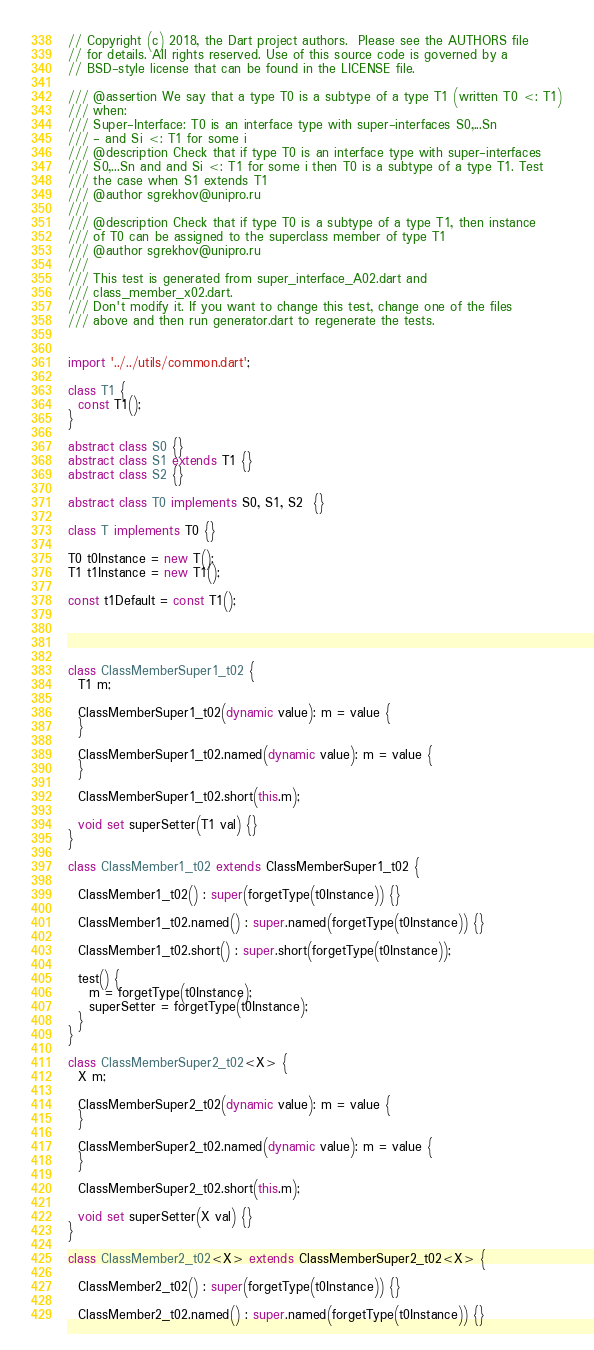Convert code to text. <code><loc_0><loc_0><loc_500><loc_500><_Dart_>// Copyright (c) 2018, the Dart project authors.  Please see the AUTHORS file
// for details. All rights reserved. Use of this source code is governed by a
// BSD-style license that can be found in the LICENSE file.

/// @assertion We say that a type T0 is a subtype of a type T1 (written T0 <: T1)
/// when:
/// Super-Interface: T0 is an interface type with super-interfaces S0,...Sn
/// - and Si <: T1 for some i
/// @description Check that if type T0 is an interface type with super-interfaces
/// S0,...Sn and and Si <: T1 for some i then T0 is a subtype of a type T1. Test
/// the case when S1 extends T1
/// @author sgrekhov@unipro.ru
///
/// @description Check that if type T0 is a subtype of a type T1, then instance
/// of T0 can be assigned to the superclass member of type T1
/// @author sgrekhov@unipro.ru
///
/// This test is generated from super_interface_A02.dart and 
/// class_member_x02.dart.
/// Don't modify it. If you want to change this test, change one of the files 
/// above and then run generator.dart to regenerate the tests.


import '../../utils/common.dart';

class T1 {
  const T1();
}

abstract class S0 {}
abstract class S1 extends T1 {}
abstract class S2 {}

abstract class T0 implements S0, S1, S2  {}

class T implements T0 {}

T0 t0Instance = new T();
T1 t1Instance = new T1();

const t1Default = const T1();




class ClassMemberSuper1_t02 {
  T1 m;

  ClassMemberSuper1_t02(dynamic value): m = value {
  }

  ClassMemberSuper1_t02.named(dynamic value): m = value {
  }

  ClassMemberSuper1_t02.short(this.m);

  void set superSetter(T1 val) {}
}

class ClassMember1_t02 extends ClassMemberSuper1_t02 {

  ClassMember1_t02() : super(forgetType(t0Instance)) {}

  ClassMember1_t02.named() : super.named(forgetType(t0Instance)) {}

  ClassMember1_t02.short() : super.short(forgetType(t0Instance));

  test() {
    m = forgetType(t0Instance);
    superSetter = forgetType(t0Instance);
  }
}

class ClassMemberSuper2_t02<X> {
  X m;

  ClassMemberSuper2_t02(dynamic value): m = value {
  }

  ClassMemberSuper2_t02.named(dynamic value): m = value {
  }

  ClassMemberSuper2_t02.short(this.m);

  void set superSetter(X val) {}
}

class ClassMember2_t02<X> extends ClassMemberSuper2_t02<X> {

  ClassMember2_t02() : super(forgetType(t0Instance)) {}

  ClassMember2_t02.named() : super.named(forgetType(t0Instance)) {}
</code> 